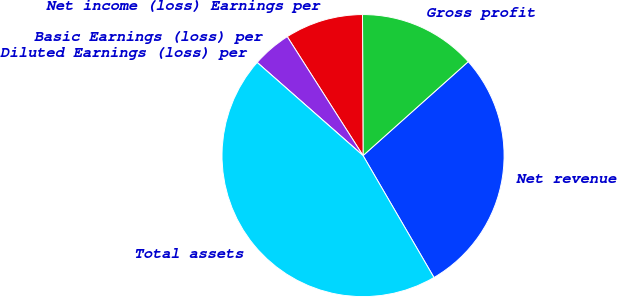Convert chart. <chart><loc_0><loc_0><loc_500><loc_500><pie_chart><fcel>Net revenue<fcel>Gross profit<fcel>Net income (loss) Earnings per<fcel>Basic Earnings (loss) per<fcel>Diluted Earnings (loss) per<fcel>Total assets<nl><fcel>28.22%<fcel>13.46%<fcel>8.97%<fcel>4.49%<fcel>0.0%<fcel>44.87%<nl></chart> 